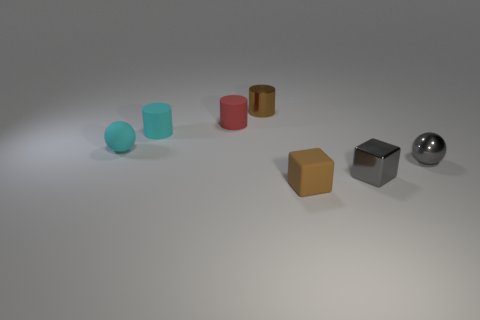There is a matte thing that is the same color as the small shiny cylinder; what is its shape?
Your answer should be very brief. Cube. Are there an equal number of small shiny things that are on the left side of the brown metallic object and yellow things?
Keep it short and to the point. Yes. How many things are tiny brown objects or things that are to the left of the tiny metal cube?
Your answer should be very brief. 5. Are there any tiny cyan things of the same shape as the brown metallic object?
Your response must be concise. Yes. Is the number of rubber cylinders that are to the right of the brown matte thing the same as the number of small gray things that are right of the gray shiny cube?
Your response must be concise. No. How many yellow objects are either tiny shiny objects or tiny metal cylinders?
Give a very brief answer. 0. How many brown metallic things have the same size as the metallic cylinder?
Provide a succinct answer. 0. There is a thing that is both in front of the small gray metallic sphere and behind the small matte cube; what color is it?
Provide a succinct answer. Gray. Are there more small gray shiny blocks behind the gray cube than large green cylinders?
Your answer should be compact. No. Are any red spheres visible?
Keep it short and to the point. No. 